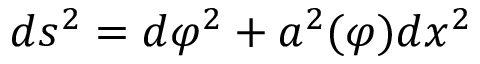<formula> <loc_0><loc_0><loc_500><loc_500>d s ^ { 2 } = d \varphi ^ { 2 } + a ^ { 2 } ( \varphi ) d x ^ { 2 }</formula> 